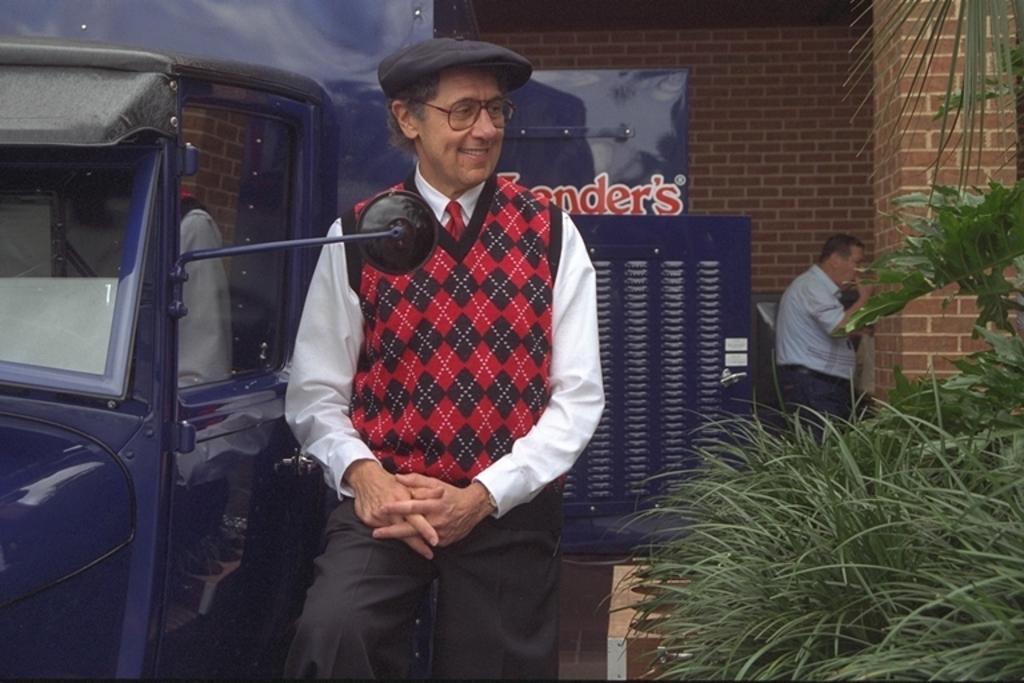In one or two sentences, can you explain what this image depicts? In the image we can see a man standing, wearing clothes, cap, spectacles and he is smiling. Here we can see the vehicle, grass plants and plant. Behind him there is another person standing and wearing clothes. Here we can see the brick wall. 